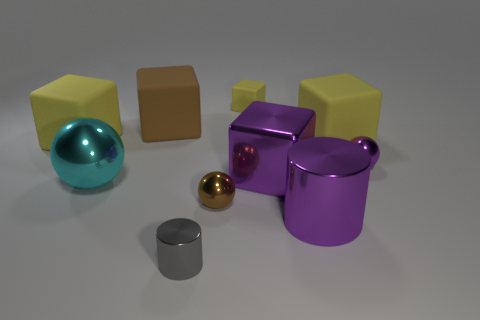What number of things are either small gray things or cubes that are to the left of the small shiny cylinder?
Offer a terse response. 3. What is the shape of the small rubber thing?
Offer a very short reply. Cube. What is the shape of the brown object behind the big rubber thing that is right of the small gray object?
Give a very brief answer. Cube. What material is the sphere that is the same color as the big metal cylinder?
Make the answer very short. Metal. There is a big cube that is the same material as the tiny cylinder; what is its color?
Keep it short and to the point. Purple. Are there any other things that have the same size as the gray cylinder?
Keep it short and to the point. Yes. There is a large matte thing right of the large brown matte object; is it the same color as the cylinder that is behind the gray thing?
Offer a very short reply. No. Is the number of big cubes in front of the small brown metallic sphere greater than the number of brown things that are in front of the brown block?
Offer a terse response. No. There is another small matte object that is the same shape as the brown rubber thing; what is its color?
Your response must be concise. Yellow. Is there any other thing that is the same shape as the gray shiny thing?
Give a very brief answer. Yes. 